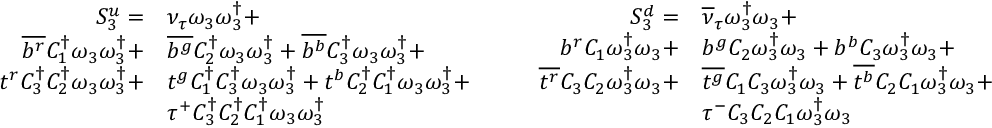<formula> <loc_0><loc_0><loc_500><loc_500>\begin{array} { r l } { S _ { 3 } ^ { u } = } & { { \nu _ { \tau } } \omega _ { 3 } \omega _ { 3 } ^ { \dagger } + } \\ { \overline { { b ^ { r } } } { C _ { 1 } ^ { \dagger } } \omega _ { 3 } \omega _ { 3 } ^ { \dagger } + } & { \overline { { b ^ { g } } } { C _ { 2 } ^ { \dagger } } \omega _ { 3 } \omega _ { 3 } ^ { \dagger } + \overline { { b ^ { b } } } { C _ { 3 } ^ { \dagger } } \omega _ { 3 } \omega _ { 3 } ^ { \dagger } + } \\ { t ^ { r } { C _ { 3 } ^ { \dagger } } { C _ { 2 } ^ { \dagger } } \omega _ { 3 } \omega _ { 3 } ^ { \dagger } + } & { t ^ { g } { C _ { 1 } ^ { \dagger } } { C _ { 3 } ^ { \dagger } } \omega _ { 3 } \omega _ { 3 } ^ { \dagger } + t ^ { b } { C _ { 2 } ^ { \dagger } } { C _ { 1 } ^ { \dagger } } \omega _ { 3 } \omega _ { 3 } ^ { \dagger } + } \\ & { \tau ^ { + } { C _ { 3 } ^ { \dagger } } { C _ { 2 } ^ { \dagger } } { C _ { 1 } ^ { \dagger } } \omega _ { 3 } \omega _ { 3 } ^ { \dagger } } \end{array} \quad \begin{array} { r l } { S _ { 3 } ^ { d } = } & { { \overline { \nu } _ { \tau } } \omega _ { 3 } ^ { \dagger } \omega _ { 3 } + } \\ { { b } ^ { r } { C _ { 1 } } \omega _ { 3 } ^ { \dagger } \omega _ { 3 } + } & { { b } ^ { g } { C _ { 2 } } \omega _ { 3 } ^ { \dagger } \omega _ { 3 } + { b } ^ { b } { C _ { 3 } } \omega _ { 3 } ^ { \dagger } \omega _ { 3 } + } \\ { \overline { { t ^ { r } } } { C _ { 3 } } { C _ { 2 } } \omega _ { 3 } ^ { \dagger } \omega _ { 3 } + } & { \overline { { t ^ { g } } } { C _ { 1 } } { C _ { 3 } } \omega _ { 3 } ^ { \dagger } \omega _ { 3 } + \overline { { t ^ { b } } } { C _ { 2 } } { C _ { 1 } } \omega _ { 3 } ^ { \dagger } \omega _ { 3 } + } \\ & { \tau ^ { - } { C _ { 3 } } { C _ { 2 } } { C _ { 1 } } \omega _ { 3 } ^ { \dagger } \omega _ { 3 } } \end{array}</formula> 